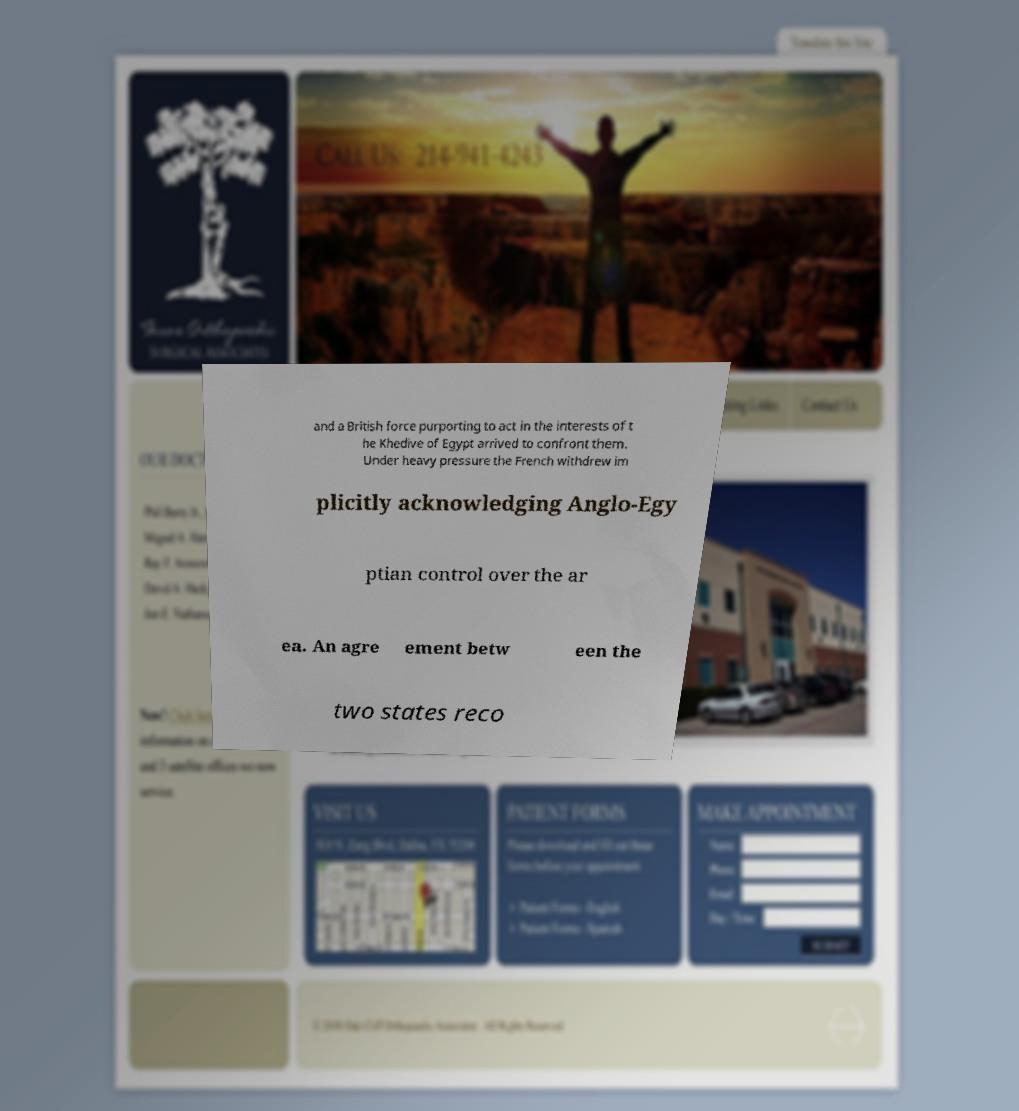What messages or text are displayed in this image? I need them in a readable, typed format. and a British force purporting to act in the interests of t he Khedive of Egypt arrived to confront them. Under heavy pressure the French withdrew im plicitly acknowledging Anglo-Egy ptian control over the ar ea. An agre ement betw een the two states reco 